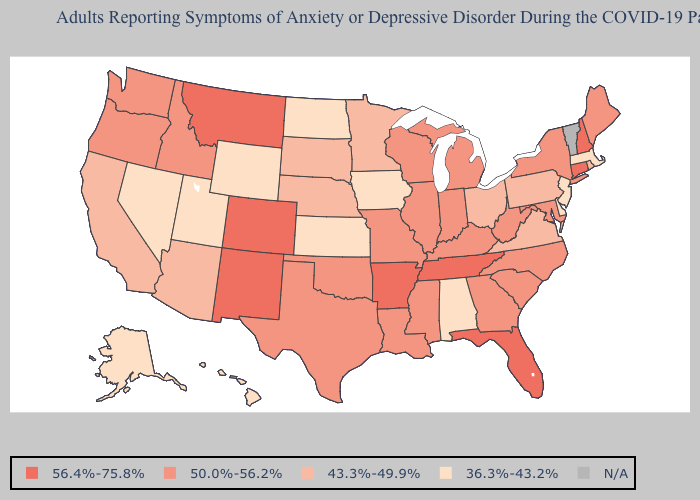Which states have the lowest value in the USA?
Quick response, please. Alabama, Alaska, Delaware, Hawaii, Iowa, Kansas, Massachusetts, Nevada, New Jersey, North Dakota, Utah, Wyoming. Name the states that have a value in the range 36.3%-43.2%?
Keep it brief. Alabama, Alaska, Delaware, Hawaii, Iowa, Kansas, Massachusetts, Nevada, New Jersey, North Dakota, Utah, Wyoming. Is the legend a continuous bar?
Concise answer only. No. What is the value of Texas?
Write a very short answer. 50.0%-56.2%. What is the value of Florida?
Keep it brief. 56.4%-75.8%. Name the states that have a value in the range 43.3%-49.9%?
Write a very short answer. Arizona, California, Minnesota, Nebraska, Ohio, Pennsylvania, Rhode Island, South Dakota, Virginia. Which states hav the highest value in the South?
Keep it brief. Arkansas, Florida, Tennessee. What is the value of North Dakota?
Keep it brief. 36.3%-43.2%. Is the legend a continuous bar?
Give a very brief answer. No. What is the lowest value in the USA?
Give a very brief answer. 36.3%-43.2%. What is the value of Maine?
Write a very short answer. 50.0%-56.2%. Does Maine have the lowest value in the Northeast?
Write a very short answer. No. Which states have the lowest value in the USA?
Short answer required. Alabama, Alaska, Delaware, Hawaii, Iowa, Kansas, Massachusetts, Nevada, New Jersey, North Dakota, Utah, Wyoming. 